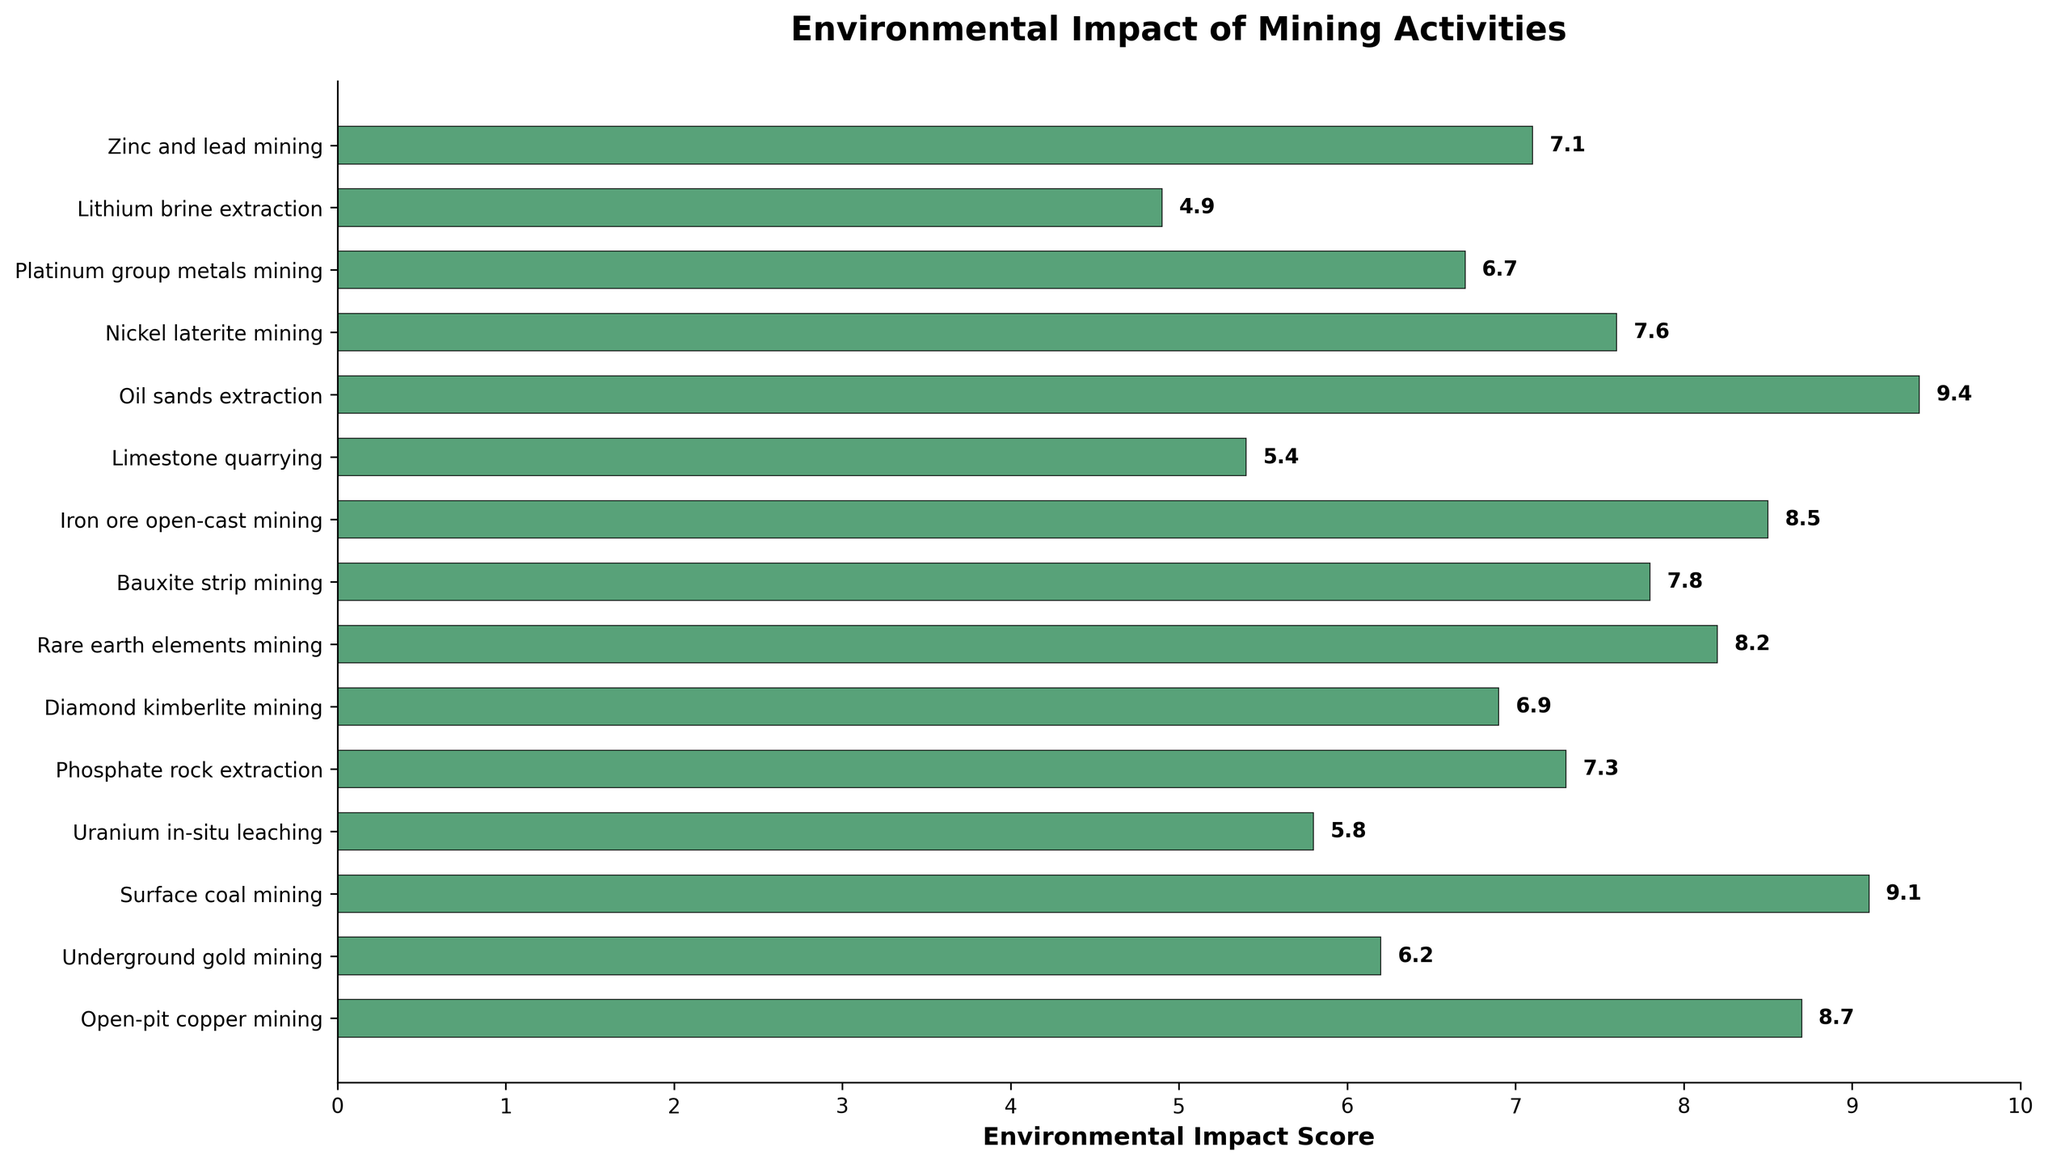Which mining activity has the highest environmental impact score? The bar representing Oil sands extraction is the longest and extends the furthest along the horizontal axis, which indicates it has the highest environmental impact score among the listed activities.
Answer: Oil sands extraction Which mining activity has the lowest environmental impact score? The bar representing Lithium brine extraction is the shortest and extends the least along the horizontal axis, which indicates it has the lowest environmental impact score among the listed activities.
Answer: Lithium brine extraction How much higher is the impact score of Oil sands extraction compared to Limestone quarrying? The environmental impact score for Oil sands extraction is 9.4, and for Limestone quarrying, it is 5.4. Subtracting the score of Limestone quarrying from Oil sands extraction: 9.4 - 5.4 = 4.0.
Answer: 4.0 What is the average environmental impact score of all listed mining activities? Add up all the environmental impact scores: 8.7 + 6.2 + 9.1 + 5.8 + 7.3 + 6.9 + 8.2 + 7.8 + 8.5 + 5.4 + 9.4 + 7.6 + 6.7 + 4.9 + 7.1 = 109.6. Divide the sum by the number of activities (15): 109.6 / 15 ≈ 7.31.
Answer: 7.31 Which mining activities have an impact score greater than 8 but less than 9? Look for the bars with scores in the range 8 to 9. The activities with scores in this range are Open-pit copper mining (8.7), Rare earth elements mining (8.2), and Iron ore open-cast mining (8.5).
Answer: Open-pit copper mining, Rare earth elements mining, Iron ore open-cast mining What is the total environmental impact score of Surface coal mining and Nickel laterite mining combined? Add the environmental impact scores of Surface coal mining (9.1) and Nickel laterite mining (7.6): 9.1 + 7.6 = 16.7.
Answer: 16.7 Which mining activity has an impact score closest to 7? Look for the bar closest to the score of 7. The environmental impact score closest to 7 is Zinc and lead mining with a score of 7.1.
Answer: Zinc and lead mining How many mining activities have an environmental impact score lower than 6? Count the number of bars with scores less than 6. The activities are Uranium in-situ leaching (5.8), Limestone quarrying (5.4), and Lithium brine extraction (4.9). There are 3 such activities.
Answer: 3 By how much does the impact score of Surface coal mining exceed that of Platinum group metals mining? The environmental impact score for Surface coal mining is 9.1, and for Platinum group metals mining, it is 6.7. Subtract the score of Platinum group metals mining from Surface coal mining: 9.1 - 6.7 = 2.4.
Answer: 2.4 